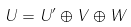Convert formula to latex. <formula><loc_0><loc_0><loc_500><loc_500>U = U ^ { \prime } \oplus V \oplus W</formula> 